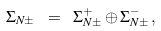<formula> <loc_0><loc_0><loc_500><loc_500>\Sigma _ { N \pm } \ = \ \Sigma _ { N \pm } ^ { + } \oplus \Sigma _ { N \pm } ^ { - } \, ,</formula> 